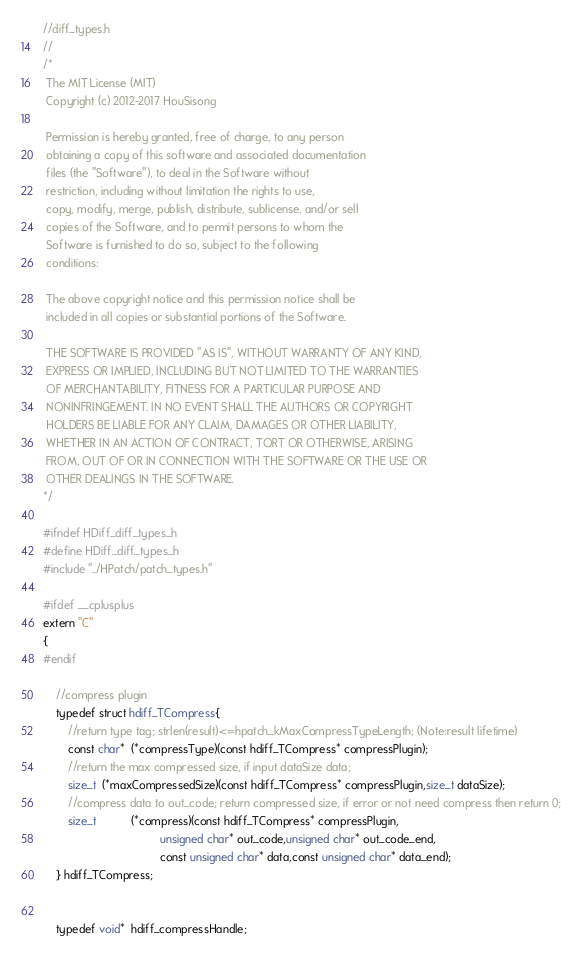Convert code to text. <code><loc_0><loc_0><loc_500><loc_500><_C_>//diff_types.h
//
/*
 The MIT License (MIT)
 Copyright (c) 2012-2017 HouSisong
 
 Permission is hereby granted, free of charge, to any person
 obtaining a copy of this software and associated documentation
 files (the "Software"), to deal in the Software without
 restriction, including without limitation the rights to use,
 copy, modify, merge, publish, distribute, sublicense, and/or sell
 copies of the Software, and to permit persons to whom the
 Software is furnished to do so, subject to the following
 conditions:
 
 The above copyright notice and this permission notice shall be
 included in all copies or substantial portions of the Software.
 
 THE SOFTWARE IS PROVIDED "AS IS", WITHOUT WARRANTY OF ANY KIND,
 EXPRESS OR IMPLIED, INCLUDING BUT NOT LIMITED TO THE WARRANTIES
 OF MERCHANTABILITY, FITNESS FOR A PARTICULAR PURPOSE AND
 NONINFRINGEMENT. IN NO EVENT SHALL THE AUTHORS OR COPYRIGHT
 HOLDERS BE LIABLE FOR ANY CLAIM, DAMAGES OR OTHER LIABILITY,
 WHETHER IN AN ACTION OF CONTRACT, TORT OR OTHERWISE, ARISING
 FROM, OUT OF OR IN CONNECTION WITH THE SOFTWARE OR THE USE OR
 OTHER DEALINGS IN THE SOFTWARE.
*/

#ifndef HDiff_diff_types_h
#define HDiff_diff_types_h
#include "../HPatch/patch_types.h"

#ifdef __cplusplus
extern "C"
{
#endif
    
    //compress plugin
    typedef struct hdiff_TCompress{
        //return type tag; strlen(result)<=hpatch_kMaxCompressTypeLength; (Note:result lifetime)
        const char*  (*compressType)(const hdiff_TCompress* compressPlugin);
        //return the max compressed size, if input dataSize data;
        size_t  (*maxCompressedSize)(const hdiff_TCompress* compressPlugin,size_t dataSize);
        //compress data to out_code; return compressed size, if error or not need compress then return 0;
        size_t           (*compress)(const hdiff_TCompress* compressPlugin,
                                     unsigned char* out_code,unsigned char* out_code_end,
                                     const unsigned char* data,const unsigned char* data_end);
    } hdiff_TCompress;
    

    typedef void*  hdiff_compressHandle;</code> 